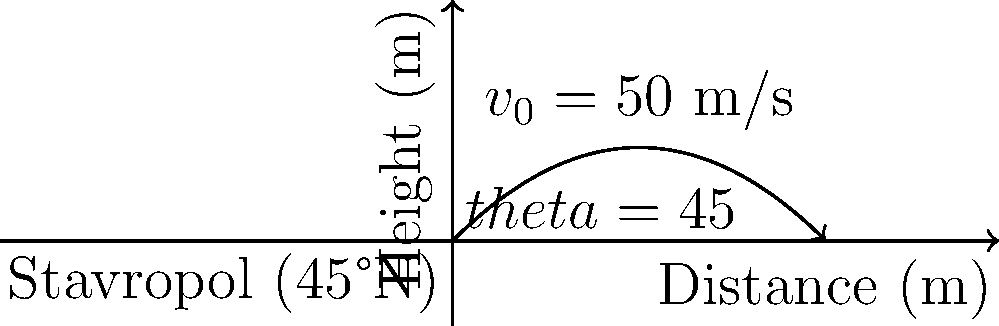As a political commentator in Stavropol (latitude 45°N), you're intrigued by a local physics demonstration. A projectile is launched from ground level with an initial velocity of 50 m/s at a 45° angle. Assuming the Earth's rotation doesn't affect the trajectory, what is the maximum height reached by the projectile? To find the maximum height, we'll follow these steps:

1) The vertical component of the initial velocity is:
   $v_{0y} = v_0 \sin(\theta) = 50 \cdot \sin(45°) = 50 \cdot \frac{\sqrt{2}}{2} \approx 35.36$ m/s

2) The time to reach maximum height is when the vertical velocity becomes zero:
   $t_{max} = \frac{v_{0y}}{g} = \frac{35.36}{9.8} \approx 3.61$ s

3) The maximum height is given by:
   $h_{max} = v_{0y}t - \frac{1}{2}gt^2$
   
   Substituting $t = t_{max}$:
   $h_{max} = 35.36 \cdot 3.61 - \frac{1}{2} \cdot 9.8 \cdot 3.61^2$
   $h_{max} = 127.65 - 63.82 = 63.83$ m

Therefore, the maximum height reached by the projectile is approximately 63.83 meters.

Note: The latitude of Stavropol (45°N) doesn't directly affect this calculation, but it would be relevant if we were considering the Coriolis effect due to Earth's rotation.
Answer: 63.83 m 